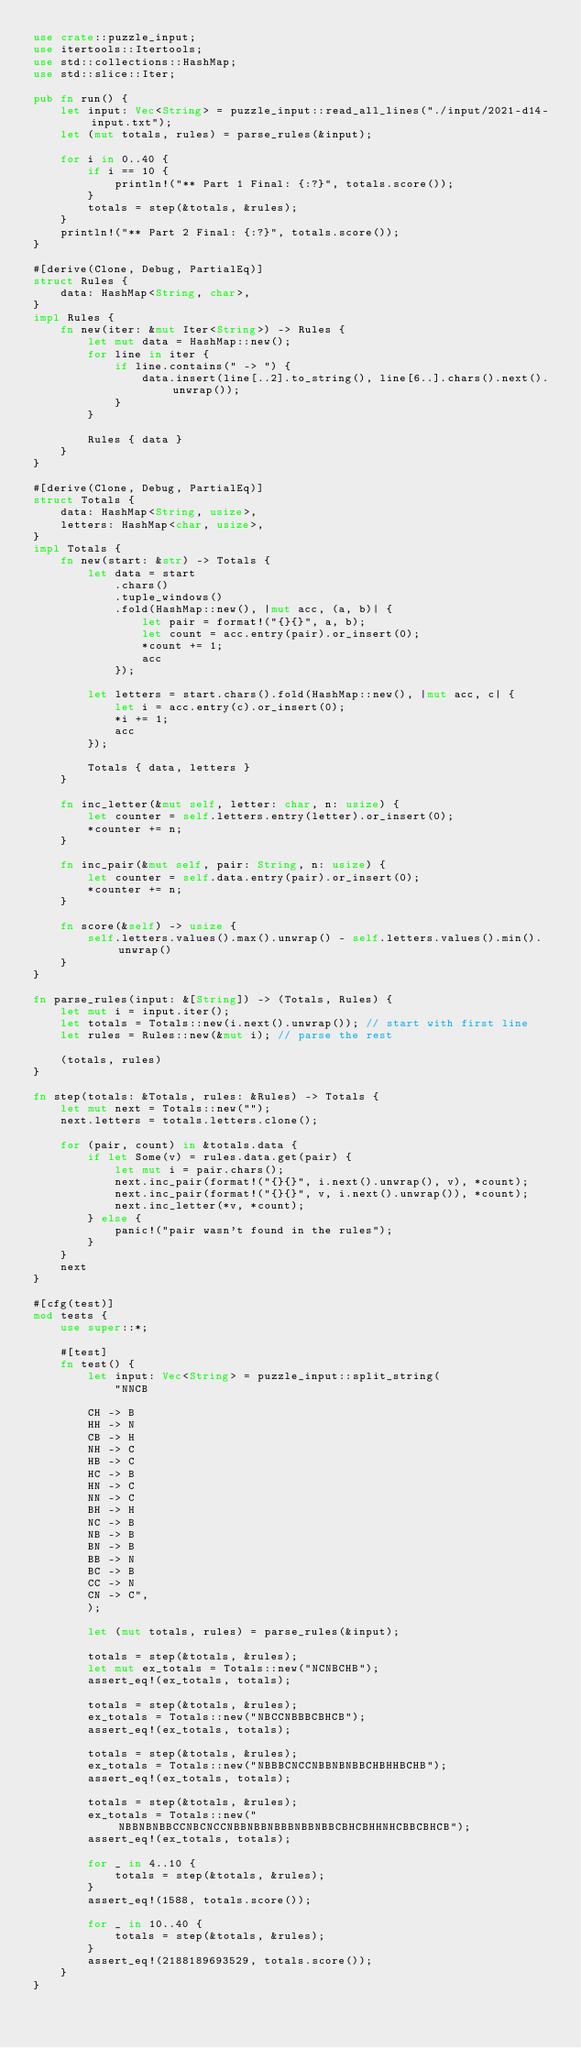<code> <loc_0><loc_0><loc_500><loc_500><_Rust_>use crate::puzzle_input;
use itertools::Itertools;
use std::collections::HashMap;
use std::slice::Iter;

pub fn run() {
    let input: Vec<String> = puzzle_input::read_all_lines("./input/2021-d14-input.txt");
    let (mut totals, rules) = parse_rules(&input);

    for i in 0..40 {
        if i == 10 {
            println!("** Part 1 Final: {:?}", totals.score());
        }
        totals = step(&totals, &rules);
    }
    println!("** Part 2 Final: {:?}", totals.score());
}

#[derive(Clone, Debug, PartialEq)]
struct Rules {
    data: HashMap<String, char>,
}
impl Rules {
    fn new(iter: &mut Iter<String>) -> Rules {
        let mut data = HashMap::new();
        for line in iter {
            if line.contains(" -> ") {
                data.insert(line[..2].to_string(), line[6..].chars().next().unwrap());
            }
        }

        Rules { data }
    }
}

#[derive(Clone, Debug, PartialEq)]
struct Totals {
    data: HashMap<String, usize>,
    letters: HashMap<char, usize>,
}
impl Totals {
    fn new(start: &str) -> Totals {
        let data = start
            .chars()
            .tuple_windows()
            .fold(HashMap::new(), |mut acc, (a, b)| {
                let pair = format!("{}{}", a, b);
                let count = acc.entry(pair).or_insert(0);
                *count += 1;
                acc
            });

        let letters = start.chars().fold(HashMap::new(), |mut acc, c| {
            let i = acc.entry(c).or_insert(0);
            *i += 1;
            acc
        });

        Totals { data, letters }
    }

    fn inc_letter(&mut self, letter: char, n: usize) {
        let counter = self.letters.entry(letter).or_insert(0);
        *counter += n;
    }

    fn inc_pair(&mut self, pair: String, n: usize) {
        let counter = self.data.entry(pair).or_insert(0);
        *counter += n;
    }

    fn score(&self) -> usize {
        self.letters.values().max().unwrap() - self.letters.values().min().unwrap()
    }
}

fn parse_rules(input: &[String]) -> (Totals, Rules) {
    let mut i = input.iter();
    let totals = Totals::new(i.next().unwrap()); // start with first line
    let rules = Rules::new(&mut i); // parse the rest

    (totals, rules)
}

fn step(totals: &Totals, rules: &Rules) -> Totals {
    let mut next = Totals::new("");
    next.letters = totals.letters.clone();

    for (pair, count) in &totals.data {
        if let Some(v) = rules.data.get(pair) {
            let mut i = pair.chars();
            next.inc_pair(format!("{}{}", i.next().unwrap(), v), *count);
            next.inc_pair(format!("{}{}", v, i.next().unwrap()), *count);
            next.inc_letter(*v, *count);
        } else {
            panic!("pair wasn't found in the rules");
        }
    }
    next
}

#[cfg(test)]
mod tests {
    use super::*;

    #[test]
    fn test() {
        let input: Vec<String> = puzzle_input::split_string(
            "NNCB

        CH -> B
        HH -> N
        CB -> H
        NH -> C
        HB -> C
        HC -> B
        HN -> C
        NN -> C
        BH -> H
        NC -> B
        NB -> B
        BN -> B
        BB -> N
        BC -> B
        CC -> N
        CN -> C",
        );

        let (mut totals, rules) = parse_rules(&input);

        totals = step(&totals, &rules);
        let mut ex_totals = Totals::new("NCNBCHB");
        assert_eq!(ex_totals, totals);

        totals = step(&totals, &rules);
        ex_totals = Totals::new("NBCCNBBBCBHCB");
        assert_eq!(ex_totals, totals);

        totals = step(&totals, &rules);
        ex_totals = Totals::new("NBBBCNCCNBBNBNBBCHBHHBCHB");
        assert_eq!(ex_totals, totals);

        totals = step(&totals, &rules);
        ex_totals = Totals::new("NBBNBNBBCCNBCNCCNBBNBBNBBBNBBNBBCBHCBHHNHCBBCBHCB");
        assert_eq!(ex_totals, totals);

        for _ in 4..10 {
            totals = step(&totals, &rules);
        }
        assert_eq!(1588, totals.score());

        for _ in 10..40 {
            totals = step(&totals, &rules);
        }
        assert_eq!(2188189693529, totals.score());
    }
}
</code> 